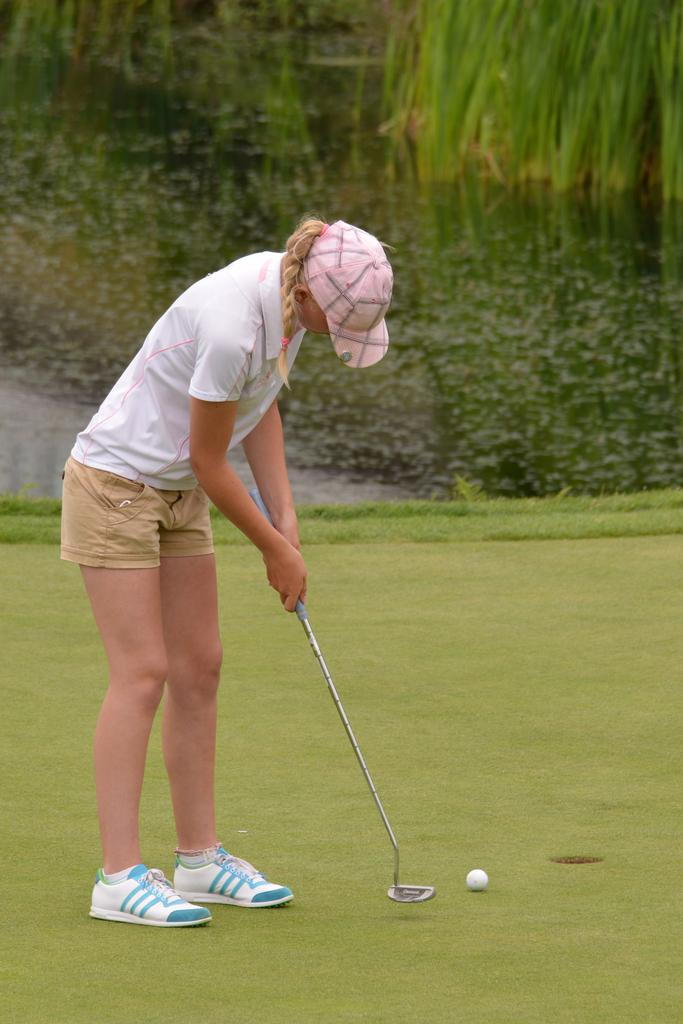What activity is the girl in the image engaged in? The girl is playing golf in the image. What is the girl wearing on her upper body? The girl is wearing a white t-shirt. What type of footwear is the girl wearing? The girl is wearing shoes. What object is essential for playing golf in the image? There is a golf ball in the image. What type of terrain is visible at the bottom of the image? There is grass at the bottom of the image. How does the girl express her feelings of pain after hitting the golf ball in the image? There is no indication of pain in the image; the girl appears to be playing golf without any visible discomfort. 